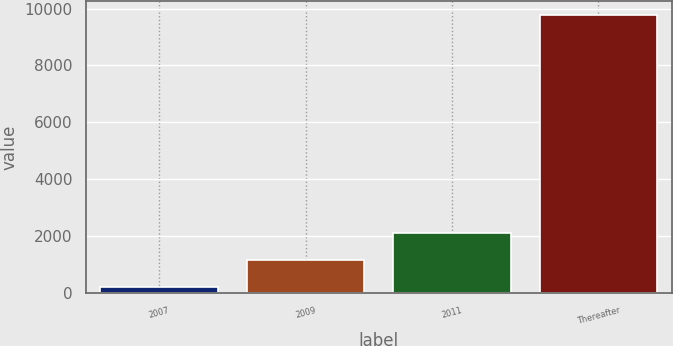Convert chart. <chart><loc_0><loc_0><loc_500><loc_500><bar_chart><fcel>2007<fcel>2009<fcel>2011<fcel>Thereafter<nl><fcel>204<fcel>1160.2<fcel>2116.4<fcel>9766<nl></chart> 